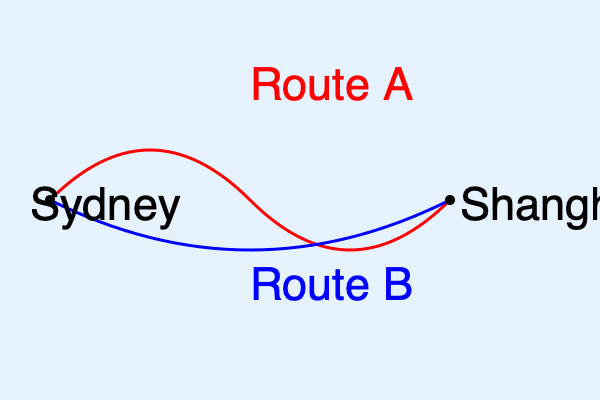As an importer based in Sydney, you're considering two shipping routes from Shanghai. Route A (red) is 15% faster but costs 20% more than Route B (blue). If Route B takes 20 days and costs $10,000, which route would be more cost-effective if you value each day of shipping time at $300? Let's break this down step-by-step:

1. Calculate the time for Route A:
   Route B takes 20 days
   Route A is 15% faster
   Route A time = 20 days × (1 - 0.15) = 17 days

2. Calculate the cost for Route A:
   Route B costs $10,000
   Route A is 20% more expensive
   Route A cost = $10,000 × 1.20 = $12,000

3. Calculate the total cost for Route B:
   Shipping cost: $10,000
   Time cost: 20 days × $300/day = $6,000
   Total cost B = $10,000 + $6,000 = $16,000

4. Calculate the total cost for Route A:
   Shipping cost: $12,000
   Time cost: 17 days × $300/day = $5,100
   Total cost A = $12,000 + $5,100 = $17,100

5. Compare the total costs:
   Route B: $16,000
   Route A: $17,100

Therefore, Route B is more cost-effective, saving $1,100 compared to Route A.
Answer: Route B 